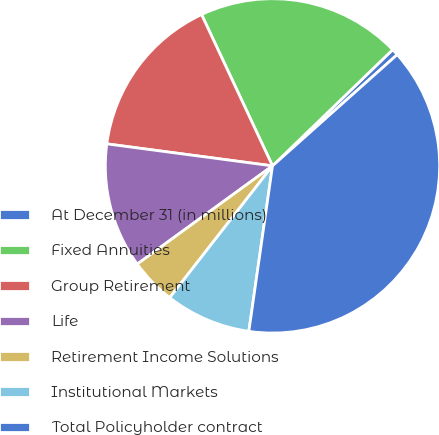<chart> <loc_0><loc_0><loc_500><loc_500><pie_chart><fcel>At December 31 (in millions)<fcel>Fixed Annuities<fcel>Group Retirement<fcel>Life<fcel>Retirement Income Solutions<fcel>Institutional Markets<fcel>Total Policyholder contract<nl><fcel>0.64%<fcel>19.74%<fcel>15.92%<fcel>12.1%<fcel>4.46%<fcel>8.28%<fcel>38.85%<nl></chart> 